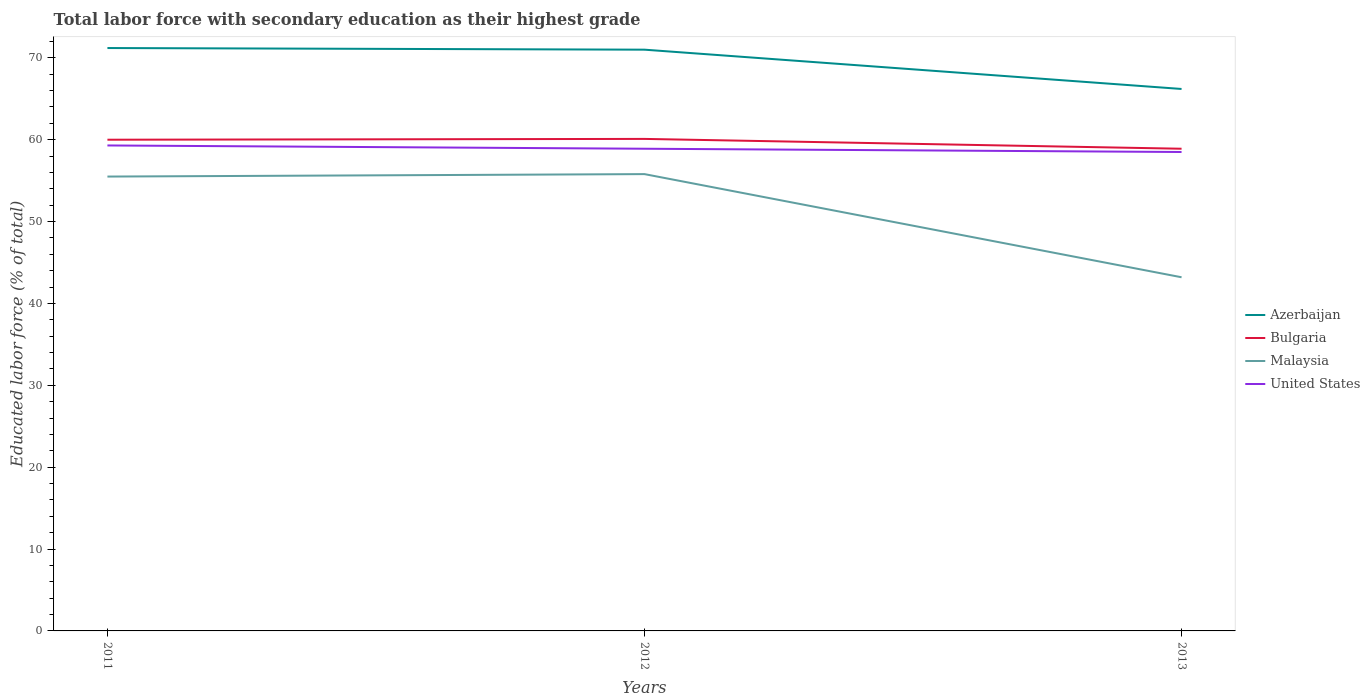Does the line corresponding to Malaysia intersect with the line corresponding to United States?
Ensure brevity in your answer.  No. Is the number of lines equal to the number of legend labels?
Your answer should be very brief. Yes. Across all years, what is the maximum percentage of total labor force with primary education in Bulgaria?
Keep it short and to the point. 58.9. In which year was the percentage of total labor force with primary education in United States maximum?
Ensure brevity in your answer.  2013. What is the total percentage of total labor force with primary education in Malaysia in the graph?
Provide a short and direct response. 12.3. What is the difference between the highest and the second highest percentage of total labor force with primary education in Bulgaria?
Provide a short and direct response. 1.2. What is the difference between the highest and the lowest percentage of total labor force with primary education in Bulgaria?
Give a very brief answer. 2. Is the percentage of total labor force with primary education in Malaysia strictly greater than the percentage of total labor force with primary education in Bulgaria over the years?
Your answer should be very brief. Yes. How many lines are there?
Your answer should be compact. 4. What is the difference between two consecutive major ticks on the Y-axis?
Your response must be concise. 10. Are the values on the major ticks of Y-axis written in scientific E-notation?
Your answer should be very brief. No. Does the graph contain any zero values?
Provide a short and direct response. No. Where does the legend appear in the graph?
Keep it short and to the point. Center right. What is the title of the graph?
Your answer should be compact. Total labor force with secondary education as their highest grade. What is the label or title of the Y-axis?
Your answer should be very brief. Educated labor force (% of total). What is the Educated labor force (% of total) of Azerbaijan in 2011?
Your answer should be very brief. 71.2. What is the Educated labor force (% of total) in Bulgaria in 2011?
Provide a short and direct response. 60. What is the Educated labor force (% of total) in Malaysia in 2011?
Your answer should be compact. 55.5. What is the Educated labor force (% of total) of United States in 2011?
Your response must be concise. 59.3. What is the Educated labor force (% of total) in Bulgaria in 2012?
Make the answer very short. 60.1. What is the Educated labor force (% of total) of Malaysia in 2012?
Provide a succinct answer. 55.8. What is the Educated labor force (% of total) of United States in 2012?
Provide a short and direct response. 58.9. What is the Educated labor force (% of total) in Azerbaijan in 2013?
Provide a succinct answer. 66.2. What is the Educated labor force (% of total) of Bulgaria in 2013?
Offer a very short reply. 58.9. What is the Educated labor force (% of total) in Malaysia in 2013?
Provide a succinct answer. 43.2. What is the Educated labor force (% of total) in United States in 2013?
Make the answer very short. 58.5. Across all years, what is the maximum Educated labor force (% of total) in Azerbaijan?
Provide a succinct answer. 71.2. Across all years, what is the maximum Educated labor force (% of total) of Bulgaria?
Offer a terse response. 60.1. Across all years, what is the maximum Educated labor force (% of total) of Malaysia?
Provide a succinct answer. 55.8. Across all years, what is the maximum Educated labor force (% of total) of United States?
Provide a succinct answer. 59.3. Across all years, what is the minimum Educated labor force (% of total) of Azerbaijan?
Your answer should be compact. 66.2. Across all years, what is the minimum Educated labor force (% of total) of Bulgaria?
Provide a short and direct response. 58.9. Across all years, what is the minimum Educated labor force (% of total) of Malaysia?
Your answer should be very brief. 43.2. Across all years, what is the minimum Educated labor force (% of total) in United States?
Keep it short and to the point. 58.5. What is the total Educated labor force (% of total) in Azerbaijan in the graph?
Ensure brevity in your answer.  208.4. What is the total Educated labor force (% of total) of Bulgaria in the graph?
Ensure brevity in your answer.  179. What is the total Educated labor force (% of total) of Malaysia in the graph?
Ensure brevity in your answer.  154.5. What is the total Educated labor force (% of total) in United States in the graph?
Provide a short and direct response. 176.7. What is the difference between the Educated labor force (% of total) of Azerbaijan in 2011 and that in 2012?
Your answer should be very brief. 0.2. What is the difference between the Educated labor force (% of total) in Malaysia in 2011 and that in 2012?
Offer a terse response. -0.3. What is the difference between the Educated labor force (% of total) of Malaysia in 2011 and that in 2013?
Provide a short and direct response. 12.3. What is the difference between the Educated labor force (% of total) of Bulgaria in 2012 and that in 2013?
Offer a terse response. 1.2. What is the difference between the Educated labor force (% of total) of United States in 2012 and that in 2013?
Your answer should be compact. 0.4. What is the difference between the Educated labor force (% of total) of Azerbaijan in 2011 and the Educated labor force (% of total) of United States in 2012?
Provide a short and direct response. 12.3. What is the difference between the Educated labor force (% of total) in Bulgaria in 2011 and the Educated labor force (% of total) in United States in 2012?
Your answer should be compact. 1.1. What is the difference between the Educated labor force (% of total) of Malaysia in 2011 and the Educated labor force (% of total) of United States in 2012?
Ensure brevity in your answer.  -3.4. What is the difference between the Educated labor force (% of total) of Azerbaijan in 2011 and the Educated labor force (% of total) of Malaysia in 2013?
Ensure brevity in your answer.  28. What is the difference between the Educated labor force (% of total) of Azerbaijan in 2011 and the Educated labor force (% of total) of United States in 2013?
Give a very brief answer. 12.7. What is the difference between the Educated labor force (% of total) of Azerbaijan in 2012 and the Educated labor force (% of total) of Malaysia in 2013?
Offer a terse response. 27.8. What is the difference between the Educated labor force (% of total) of Azerbaijan in 2012 and the Educated labor force (% of total) of United States in 2013?
Ensure brevity in your answer.  12.5. What is the difference between the Educated labor force (% of total) in Bulgaria in 2012 and the Educated labor force (% of total) in United States in 2013?
Give a very brief answer. 1.6. What is the difference between the Educated labor force (% of total) of Malaysia in 2012 and the Educated labor force (% of total) of United States in 2013?
Your answer should be compact. -2.7. What is the average Educated labor force (% of total) of Azerbaijan per year?
Offer a very short reply. 69.47. What is the average Educated labor force (% of total) of Bulgaria per year?
Keep it short and to the point. 59.67. What is the average Educated labor force (% of total) of Malaysia per year?
Your answer should be compact. 51.5. What is the average Educated labor force (% of total) in United States per year?
Offer a terse response. 58.9. In the year 2011, what is the difference between the Educated labor force (% of total) in Azerbaijan and Educated labor force (% of total) in Bulgaria?
Provide a short and direct response. 11.2. In the year 2011, what is the difference between the Educated labor force (% of total) of Bulgaria and Educated labor force (% of total) of Malaysia?
Your answer should be very brief. 4.5. In the year 2012, what is the difference between the Educated labor force (% of total) of Azerbaijan and Educated labor force (% of total) of Malaysia?
Give a very brief answer. 15.2. In the year 2012, what is the difference between the Educated labor force (% of total) in Azerbaijan and Educated labor force (% of total) in United States?
Offer a terse response. 12.1. In the year 2012, what is the difference between the Educated labor force (% of total) in Bulgaria and Educated labor force (% of total) in United States?
Keep it short and to the point. 1.2. In the year 2012, what is the difference between the Educated labor force (% of total) in Malaysia and Educated labor force (% of total) in United States?
Your answer should be very brief. -3.1. In the year 2013, what is the difference between the Educated labor force (% of total) of Azerbaijan and Educated labor force (% of total) of Bulgaria?
Offer a very short reply. 7.3. In the year 2013, what is the difference between the Educated labor force (% of total) of Azerbaijan and Educated labor force (% of total) of United States?
Provide a short and direct response. 7.7. In the year 2013, what is the difference between the Educated labor force (% of total) of Bulgaria and Educated labor force (% of total) of Malaysia?
Provide a short and direct response. 15.7. In the year 2013, what is the difference between the Educated labor force (% of total) in Bulgaria and Educated labor force (% of total) in United States?
Offer a terse response. 0.4. In the year 2013, what is the difference between the Educated labor force (% of total) in Malaysia and Educated labor force (% of total) in United States?
Offer a very short reply. -15.3. What is the ratio of the Educated labor force (% of total) of Azerbaijan in 2011 to that in 2012?
Provide a short and direct response. 1. What is the ratio of the Educated labor force (% of total) in Bulgaria in 2011 to that in 2012?
Give a very brief answer. 1. What is the ratio of the Educated labor force (% of total) of Malaysia in 2011 to that in 2012?
Provide a succinct answer. 0.99. What is the ratio of the Educated labor force (% of total) of United States in 2011 to that in 2012?
Keep it short and to the point. 1.01. What is the ratio of the Educated labor force (% of total) of Azerbaijan in 2011 to that in 2013?
Your response must be concise. 1.08. What is the ratio of the Educated labor force (% of total) in Bulgaria in 2011 to that in 2013?
Ensure brevity in your answer.  1.02. What is the ratio of the Educated labor force (% of total) of Malaysia in 2011 to that in 2013?
Provide a short and direct response. 1.28. What is the ratio of the Educated labor force (% of total) of United States in 2011 to that in 2013?
Provide a short and direct response. 1.01. What is the ratio of the Educated labor force (% of total) of Azerbaijan in 2012 to that in 2013?
Your answer should be compact. 1.07. What is the ratio of the Educated labor force (% of total) in Bulgaria in 2012 to that in 2013?
Offer a terse response. 1.02. What is the ratio of the Educated labor force (% of total) of Malaysia in 2012 to that in 2013?
Give a very brief answer. 1.29. What is the ratio of the Educated labor force (% of total) of United States in 2012 to that in 2013?
Ensure brevity in your answer.  1.01. What is the difference between the highest and the second highest Educated labor force (% of total) in Malaysia?
Make the answer very short. 0.3. What is the difference between the highest and the lowest Educated labor force (% of total) in Bulgaria?
Offer a terse response. 1.2. What is the difference between the highest and the lowest Educated labor force (% of total) of Malaysia?
Provide a succinct answer. 12.6. What is the difference between the highest and the lowest Educated labor force (% of total) in United States?
Offer a terse response. 0.8. 